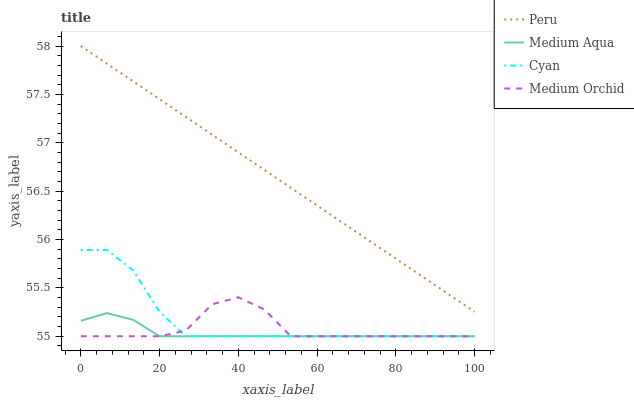Does Medium Aqua have the minimum area under the curve?
Answer yes or no. Yes. Does Peru have the maximum area under the curve?
Answer yes or no. Yes. Does Medium Orchid have the minimum area under the curve?
Answer yes or no. No. Does Medium Orchid have the maximum area under the curve?
Answer yes or no. No. Is Peru the smoothest?
Answer yes or no. Yes. Is Medium Orchid the roughest?
Answer yes or no. Yes. Is Medium Aqua the smoothest?
Answer yes or no. No. Is Medium Aqua the roughest?
Answer yes or no. No. Does Peru have the lowest value?
Answer yes or no. No. Does Peru have the highest value?
Answer yes or no. Yes. Does Medium Orchid have the highest value?
Answer yes or no. No. Is Cyan less than Peru?
Answer yes or no. Yes. Is Peru greater than Medium Aqua?
Answer yes or no. Yes. Does Medium Aqua intersect Cyan?
Answer yes or no. Yes. Is Medium Aqua less than Cyan?
Answer yes or no. No. Is Medium Aqua greater than Cyan?
Answer yes or no. No. Does Cyan intersect Peru?
Answer yes or no. No. 